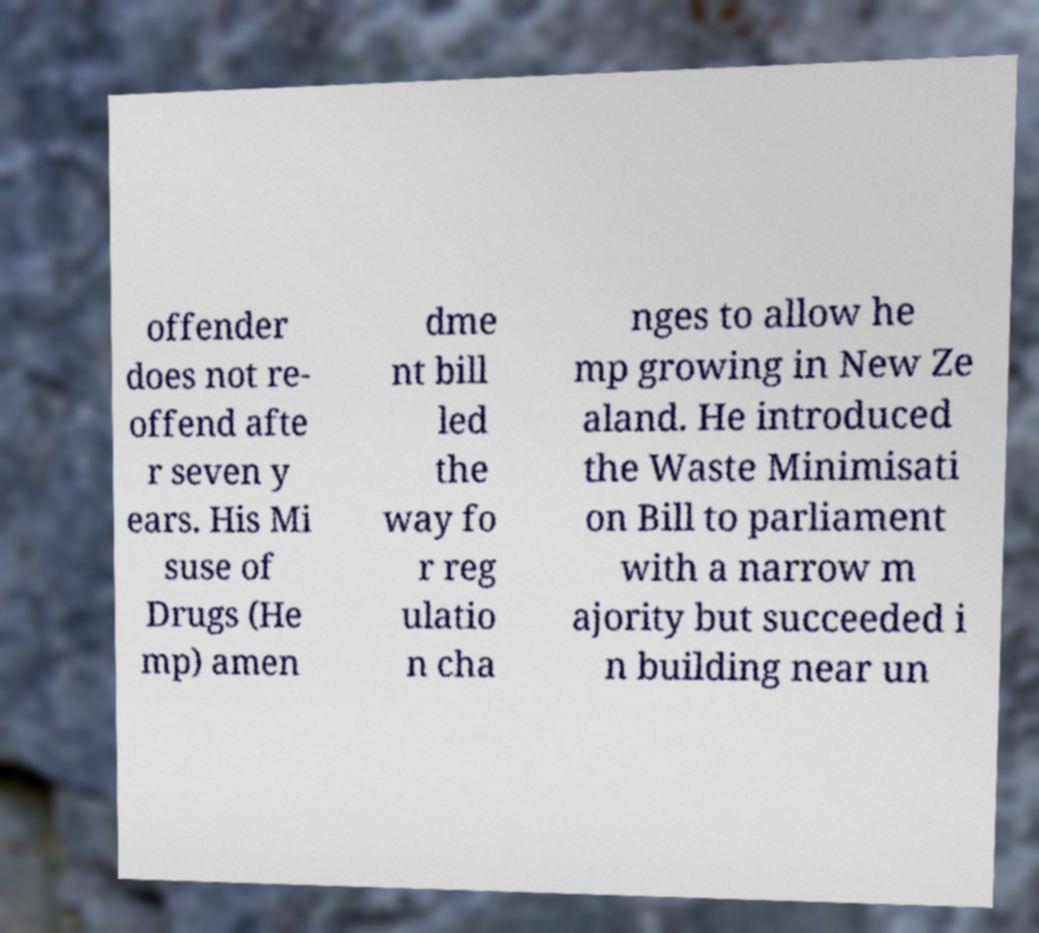I need the written content from this picture converted into text. Can you do that? offender does not re- offend afte r seven y ears. His Mi suse of Drugs (He mp) amen dme nt bill led the way fo r reg ulatio n cha nges to allow he mp growing in New Ze aland. He introduced the Waste Minimisati on Bill to parliament with a narrow m ajority but succeeded i n building near un 